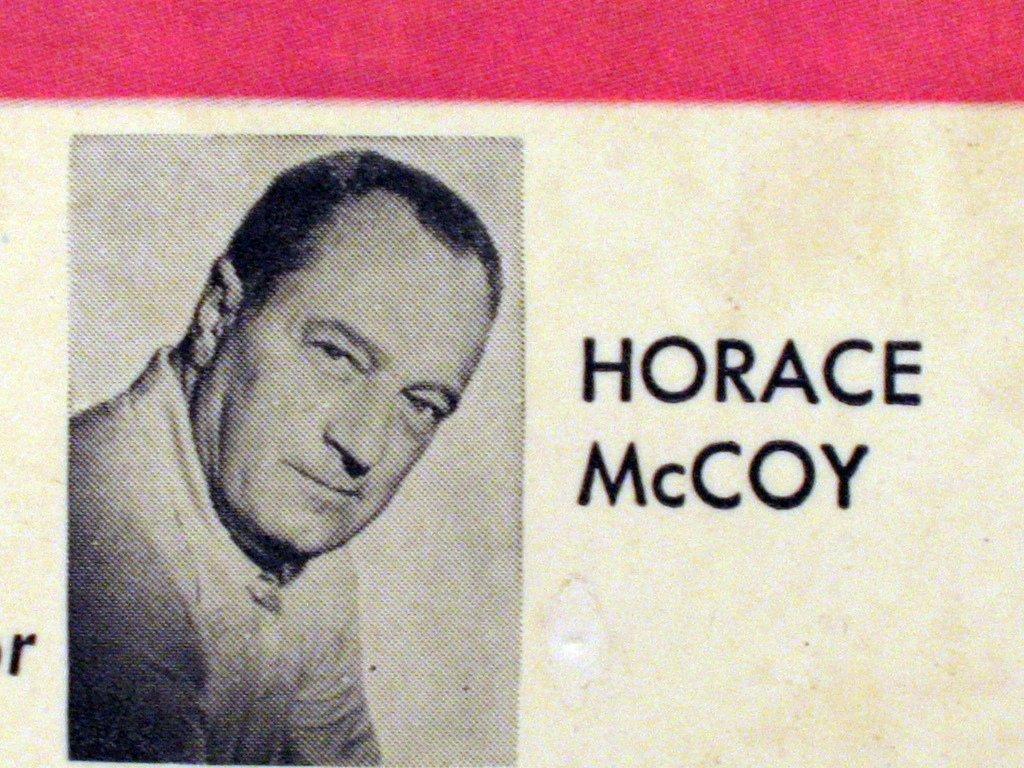How would you summarize this image in a sentence or two? There is a person's photo with something written on that. 